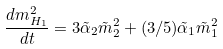<formula> <loc_0><loc_0><loc_500><loc_500>\frac { d m _ { H _ { 1 } } ^ { 2 } } { d t } = 3 { \tilde { \alpha } } _ { 2 } { \tilde { m } } _ { 2 } ^ { 2 } + ( 3 / 5 ) \tilde { \alpha } _ { 1 } { \tilde { m } } _ { 1 } ^ { 2 }</formula> 